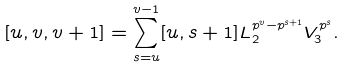Convert formula to latex. <formula><loc_0><loc_0><loc_500><loc_500>[ u , v , v + 1 ] = \sum _ { s = u } ^ { v - 1 } [ u , s + 1 ] L _ { 2 } ^ { p ^ { v } - p ^ { s + 1 } } V _ { 3 } ^ { p ^ { s } } .</formula> 